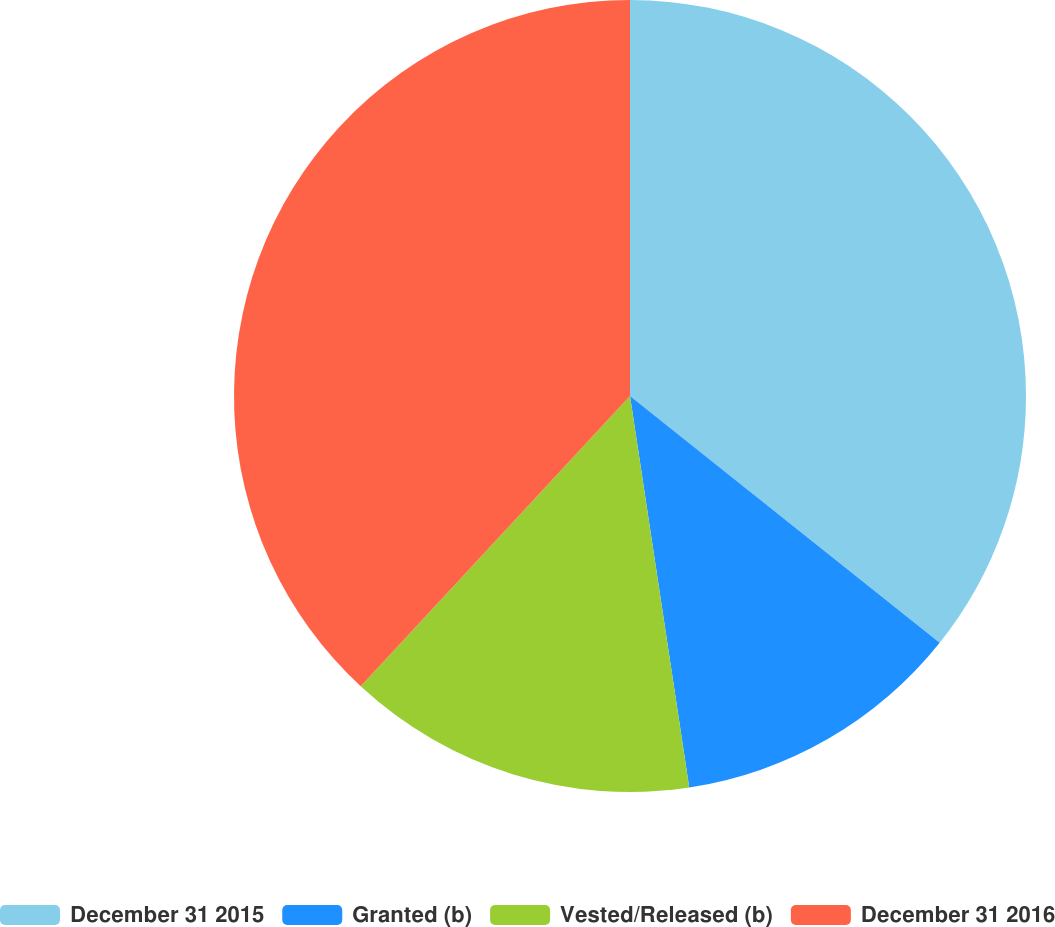<chart> <loc_0><loc_0><loc_500><loc_500><pie_chart><fcel>December 31 2015<fcel>Granted (b)<fcel>Vested/Released (b)<fcel>December 31 2016<nl><fcel>35.71%<fcel>11.9%<fcel>14.29%<fcel>38.1%<nl></chart> 